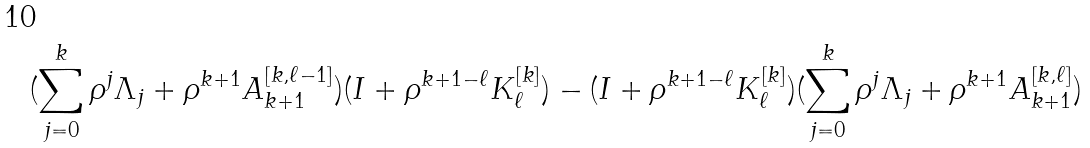Convert formula to latex. <formula><loc_0><loc_0><loc_500><loc_500>( \sum _ { j = 0 } ^ { k } \rho ^ { j } \Lambda _ { j } + \rho ^ { k + 1 } A ^ { [ k , \ell - 1 ] } _ { k + 1 } ) ( I + \rho ^ { k + 1 - \ell } K ^ { [ k ] } _ { \ell } ) - ( I + \rho ^ { k + 1 - \ell } K ^ { [ k ] } _ { \ell } ) ( \sum _ { j = 0 } ^ { k } \rho ^ { j } \Lambda _ { j } + \rho ^ { k + 1 } A ^ { [ k , \ell ] } _ { k + 1 } )</formula> 